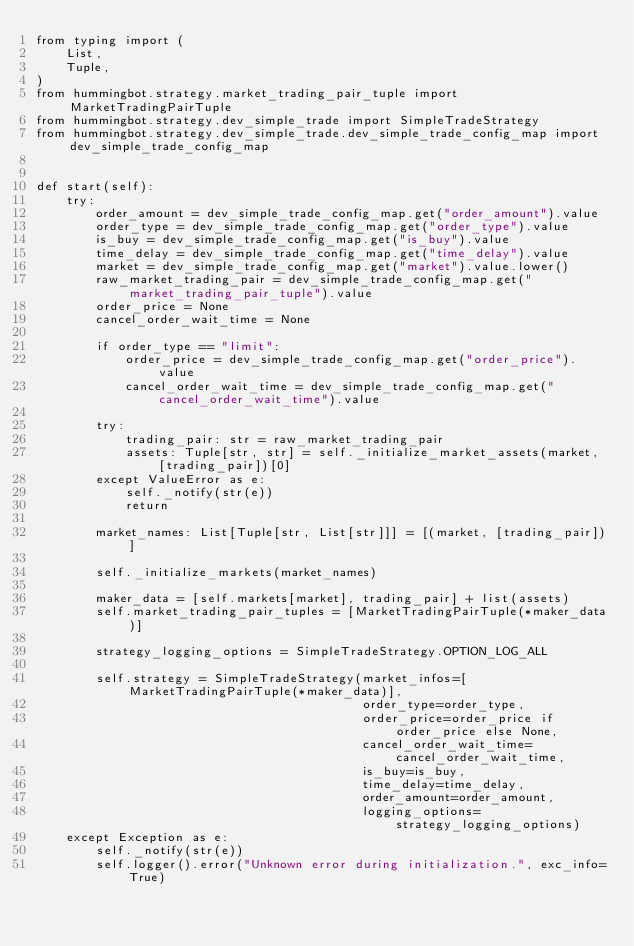Convert code to text. <code><loc_0><loc_0><loc_500><loc_500><_Python_>from typing import (
    List,
    Tuple,
)
from hummingbot.strategy.market_trading_pair_tuple import MarketTradingPairTuple
from hummingbot.strategy.dev_simple_trade import SimpleTradeStrategy
from hummingbot.strategy.dev_simple_trade.dev_simple_trade_config_map import dev_simple_trade_config_map


def start(self):
    try:
        order_amount = dev_simple_trade_config_map.get("order_amount").value
        order_type = dev_simple_trade_config_map.get("order_type").value
        is_buy = dev_simple_trade_config_map.get("is_buy").value
        time_delay = dev_simple_trade_config_map.get("time_delay").value
        market = dev_simple_trade_config_map.get("market").value.lower()
        raw_market_trading_pair = dev_simple_trade_config_map.get("market_trading_pair_tuple").value
        order_price = None
        cancel_order_wait_time = None

        if order_type == "limit":
            order_price = dev_simple_trade_config_map.get("order_price").value
            cancel_order_wait_time = dev_simple_trade_config_map.get("cancel_order_wait_time").value

        try:
            trading_pair: str = raw_market_trading_pair
            assets: Tuple[str, str] = self._initialize_market_assets(market, [trading_pair])[0]
        except ValueError as e:
            self._notify(str(e))
            return

        market_names: List[Tuple[str, List[str]]] = [(market, [trading_pair])]

        self._initialize_markets(market_names)

        maker_data = [self.markets[market], trading_pair] + list(assets)
        self.market_trading_pair_tuples = [MarketTradingPairTuple(*maker_data)]

        strategy_logging_options = SimpleTradeStrategy.OPTION_LOG_ALL

        self.strategy = SimpleTradeStrategy(market_infos=[MarketTradingPairTuple(*maker_data)],
                                            order_type=order_type,
                                            order_price=order_price if order_price else None,
                                            cancel_order_wait_time=cancel_order_wait_time,
                                            is_buy=is_buy,
                                            time_delay=time_delay,
                                            order_amount=order_amount,
                                            logging_options=strategy_logging_options)
    except Exception as e:
        self._notify(str(e))
        self.logger().error("Unknown error during initialization.", exc_info=True)
</code> 